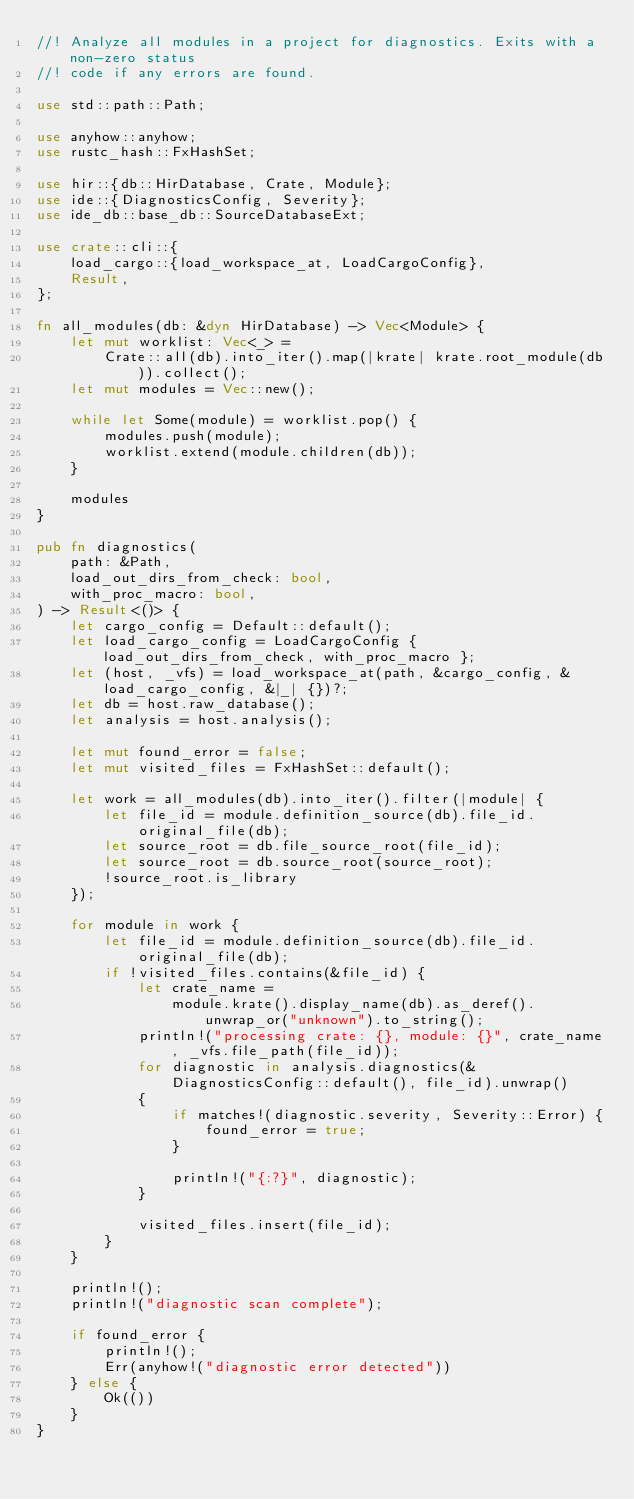<code> <loc_0><loc_0><loc_500><loc_500><_Rust_>//! Analyze all modules in a project for diagnostics. Exits with a non-zero status
//! code if any errors are found.

use std::path::Path;

use anyhow::anyhow;
use rustc_hash::FxHashSet;

use hir::{db::HirDatabase, Crate, Module};
use ide::{DiagnosticsConfig, Severity};
use ide_db::base_db::SourceDatabaseExt;

use crate::cli::{
    load_cargo::{load_workspace_at, LoadCargoConfig},
    Result,
};

fn all_modules(db: &dyn HirDatabase) -> Vec<Module> {
    let mut worklist: Vec<_> =
        Crate::all(db).into_iter().map(|krate| krate.root_module(db)).collect();
    let mut modules = Vec::new();

    while let Some(module) = worklist.pop() {
        modules.push(module);
        worklist.extend(module.children(db));
    }

    modules
}

pub fn diagnostics(
    path: &Path,
    load_out_dirs_from_check: bool,
    with_proc_macro: bool,
) -> Result<()> {
    let cargo_config = Default::default();
    let load_cargo_config = LoadCargoConfig { load_out_dirs_from_check, with_proc_macro };
    let (host, _vfs) = load_workspace_at(path, &cargo_config, &load_cargo_config, &|_| {})?;
    let db = host.raw_database();
    let analysis = host.analysis();

    let mut found_error = false;
    let mut visited_files = FxHashSet::default();

    let work = all_modules(db).into_iter().filter(|module| {
        let file_id = module.definition_source(db).file_id.original_file(db);
        let source_root = db.file_source_root(file_id);
        let source_root = db.source_root(source_root);
        !source_root.is_library
    });

    for module in work {
        let file_id = module.definition_source(db).file_id.original_file(db);
        if !visited_files.contains(&file_id) {
            let crate_name =
                module.krate().display_name(db).as_deref().unwrap_or("unknown").to_string();
            println!("processing crate: {}, module: {}", crate_name, _vfs.file_path(file_id));
            for diagnostic in analysis.diagnostics(&DiagnosticsConfig::default(), file_id).unwrap()
            {
                if matches!(diagnostic.severity, Severity::Error) {
                    found_error = true;
                }

                println!("{:?}", diagnostic);
            }

            visited_files.insert(file_id);
        }
    }

    println!();
    println!("diagnostic scan complete");

    if found_error {
        println!();
        Err(anyhow!("diagnostic error detected"))
    } else {
        Ok(())
    }
}
</code> 